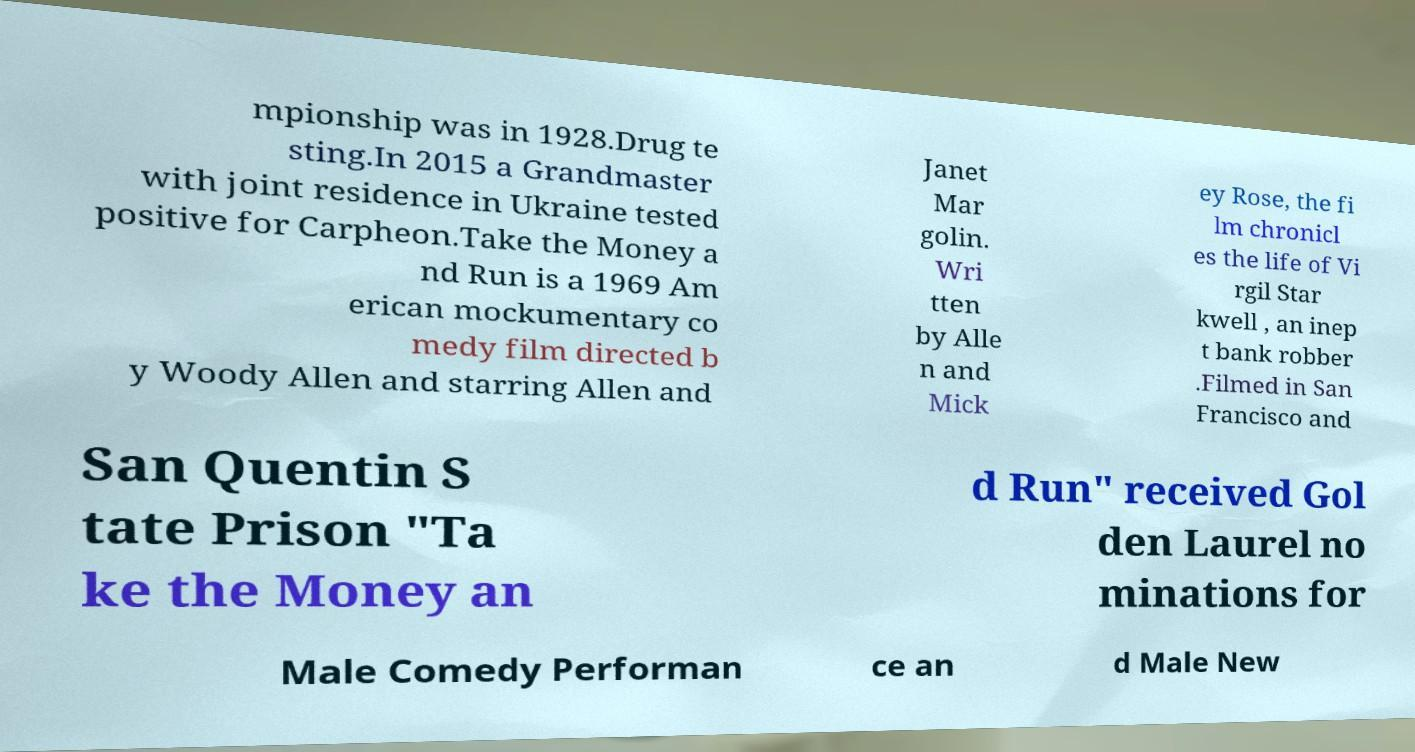Could you assist in decoding the text presented in this image and type it out clearly? mpionship was in 1928.Drug te sting.In 2015 a Grandmaster with joint residence in Ukraine tested positive for Carpheon.Take the Money a nd Run is a 1969 Am erican mockumentary co medy film directed b y Woody Allen and starring Allen and Janet Mar golin. Wri tten by Alle n and Mick ey Rose, the fi lm chronicl es the life of Vi rgil Star kwell , an inep t bank robber .Filmed in San Francisco and San Quentin S tate Prison "Ta ke the Money an d Run" received Gol den Laurel no minations for Male Comedy Performan ce an d Male New 